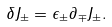<formula> <loc_0><loc_0><loc_500><loc_500>\delta J _ { \pm } = \epsilon _ { \pm } \partial _ { \mp } J _ { \pm } .</formula> 